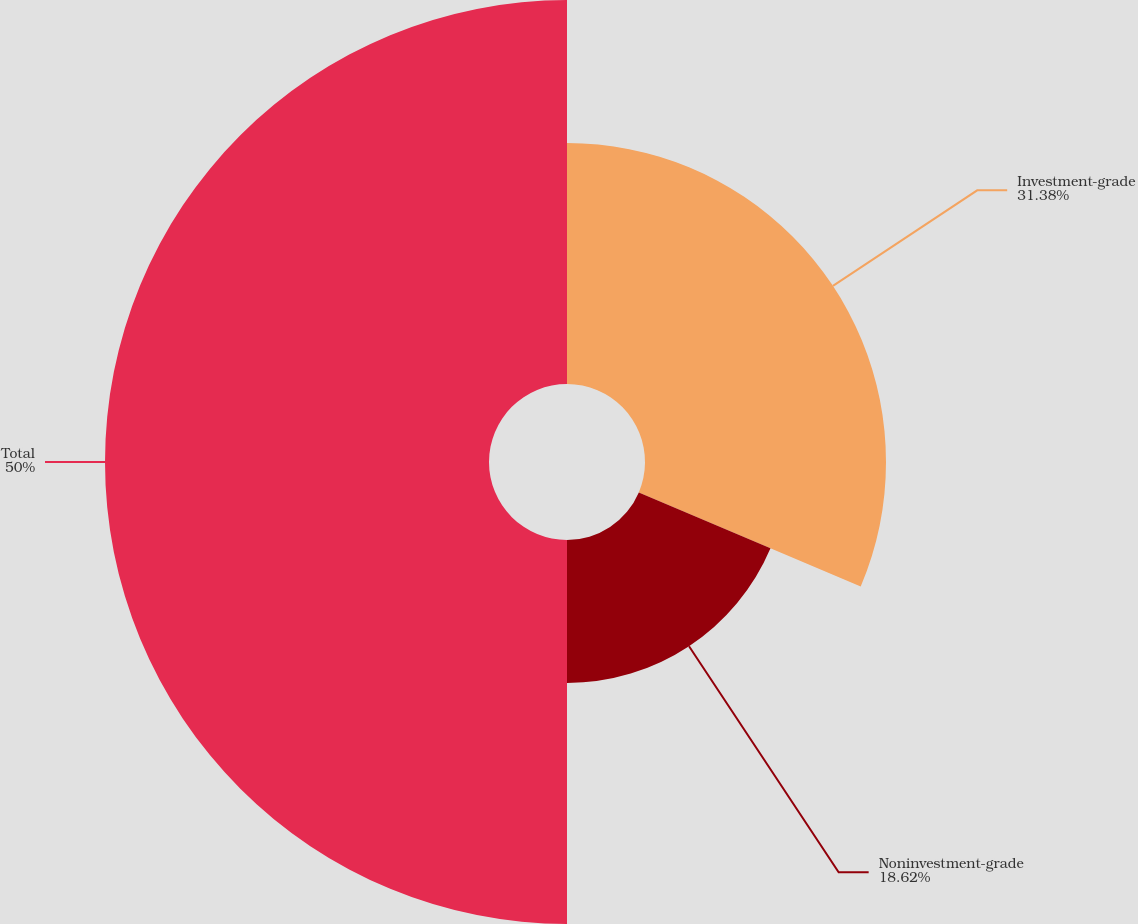Convert chart to OTSL. <chart><loc_0><loc_0><loc_500><loc_500><pie_chart><fcel>Investment-grade<fcel>Noninvestment-grade<fcel>Total<nl><fcel>31.38%<fcel>18.62%<fcel>50.0%<nl></chart> 